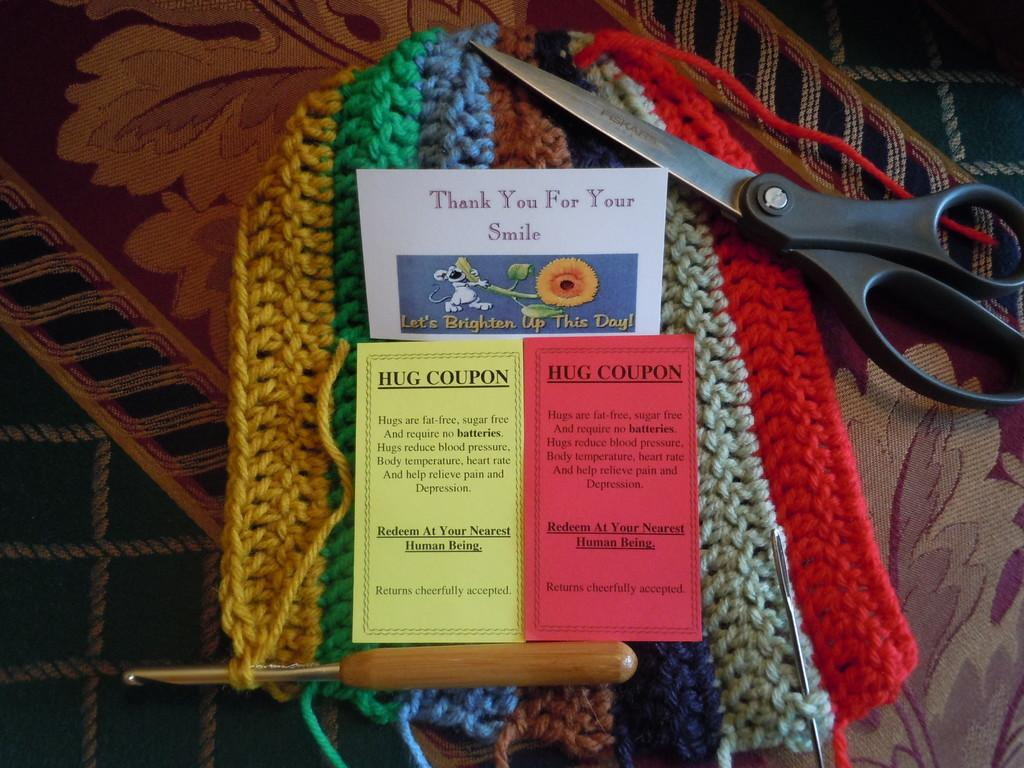What is located in the center of the image? There are banners in the center of the image. What type of items can be seen in the image besides the banners? There are woolens in different colors and a scissor in the image. What tools are used for knitting or crocheting in the image? Woolen needles are present in the image. What type of seed is being planted in the alley in the image? There is no alley or seed present in the image. How many knees are visible in the image? There are no knees visible in the image. 